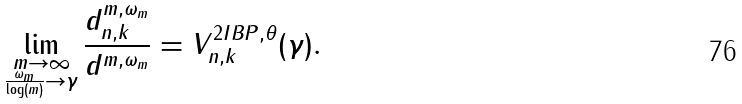<formula> <loc_0><loc_0><loc_500><loc_500>\lim _ { \substack { m \to \infty \\ \frac { \omega _ { m } } { \log ( m ) } \to \gamma } } \frac { d _ { n , k } ^ { m , \omega _ { m } } } { d ^ { m , \omega _ { m } } } = V ^ { 2 I B P , \theta } _ { n , k } ( \gamma ) .</formula> 